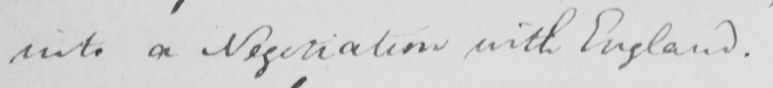Transcribe the text shown in this historical manuscript line. into a Negotiation with England . 